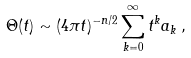<formula> <loc_0><loc_0><loc_500><loc_500>\Theta ( t ) \sim ( 4 \pi t ) ^ { - n / 2 } \sum _ { k = 0 } ^ { \infty } t ^ { k } a _ { k } \, ,</formula> 